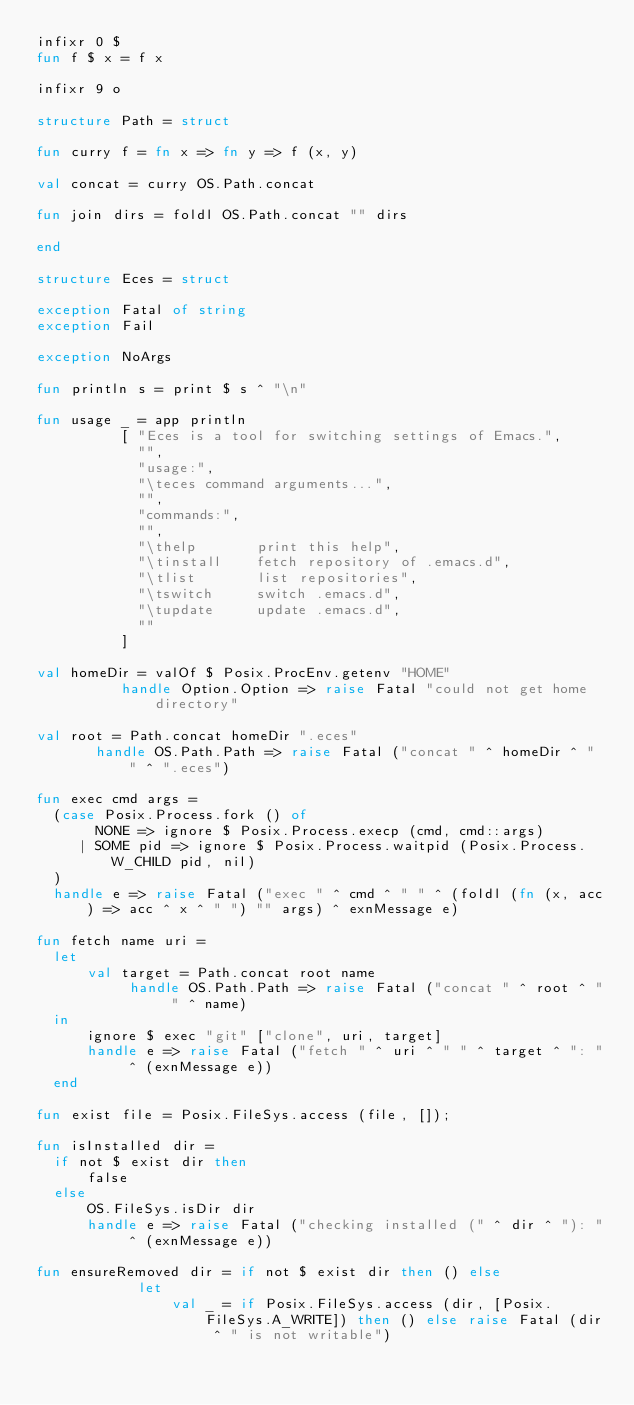Convert code to text. <code><loc_0><loc_0><loc_500><loc_500><_SML_>infixr 0 $
fun f $ x = f x

infixr 9 o

structure Path = struct

fun curry f = fn x => fn y => f (x, y)

val concat = curry OS.Path.concat

fun join dirs = foldl OS.Path.concat "" dirs

end

structure Eces = struct

exception Fatal of string
exception Fail

exception NoArgs

fun println s = print $ s ^ "\n"

fun usage _ = app println
		  [ "Eces is a tool for switching settings of Emacs.",
		    "",
		    "usage:",
		    "\teces command arguments...",
		    "",
		    "commands:",
		    "",
		    "\thelp       print this help",
		    "\tinstall    fetch repository of .emacs.d",
		    "\tlist       list repositories",
		    "\tswitch     switch .emacs.d",
		    "\tupdate     update .emacs.d",
		    ""
		  ]

val homeDir = valOf $ Posix.ProcEnv.getenv "HOME"
	      handle Option.Option => raise Fatal "could not get home directory"

val root = Path.concat homeDir ".eces"
	   handle OS.Path.Path => raise Fatal ("concat " ^ homeDir ^ " " ^ ".eces")

fun exec cmd args =
  (case Posix.Process.fork () of
       NONE => ignore $ Posix.Process.execp (cmd, cmd::args)
     | SOME pid => ignore $ Posix.Process.waitpid (Posix.Process.W_CHILD pid, nil)
  )
  handle e => raise Fatal ("exec " ^ cmd ^ " " ^ (foldl (fn (x, acc) => acc ^ x ^ " ") "" args) ^ exnMessage e)

fun fetch name uri =
  let
      val target = Path.concat root name
		   handle OS.Path.Path => raise Fatal ("concat " ^ root ^ " " ^ name)
  in
      ignore $ exec "git" ["clone", uri, target]
      handle e => raise Fatal ("fetch " ^ uri ^ " " ^ target ^ ": " ^ (exnMessage e))
  end

fun exist file = Posix.FileSys.access (file, []);

fun isInstalled dir =
  if not $ exist dir then
      false
  else
      OS.FileSys.isDir dir
      handle e => raise Fatal ("checking installed (" ^ dir ^ "): " ^ (exnMessage e))

fun ensureRemoved dir = if not $ exist dir then () else
			let
			    val _ = if Posix.FileSys.access (dir, [Posix.FileSys.A_WRITE]) then () else raise Fatal (dir ^ " is not writable")</code> 